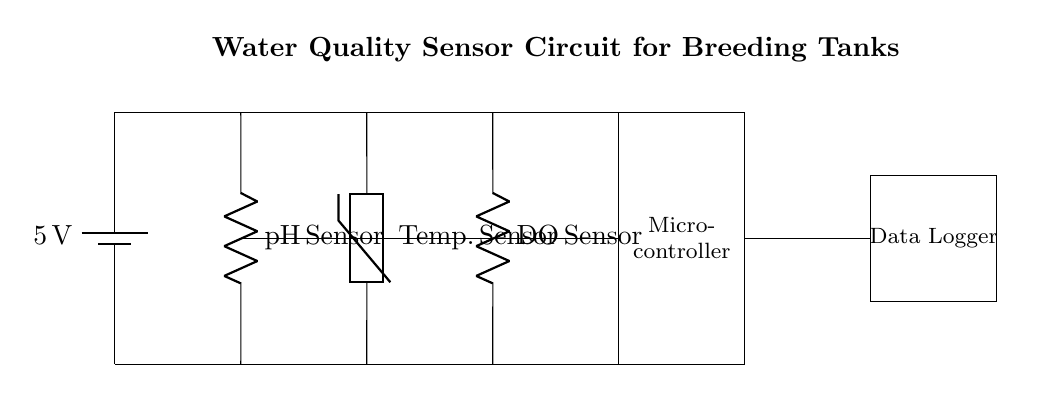What is the main power supply voltage for this circuit? The main power supply voltage is indicated by the battery symbol at the start of the circuit, which specifies it as 5 volts.
Answer: 5 volts What type of sensors are used in this circuit? Three types of sensors are shown: a pH sensor, a temperature sensor (thermistor), and a dissolved oxygen sensor, each labeled accordingly.
Answer: pH sensor, temperature sensor, dissolved oxygen sensor How many sensors connect to the microcontroller? The diagram shows three distinct sensors (pH, temperature, and dissolved oxygen) all connecting to a single microcontroller, indicated by the lines converging into the microcontroller from each sensor.
Answer: Three sensors What is the function of the data logger in this circuit? The data logger is connected at the output of the microcontroller, taking in the processed data from the sensors, emphasizing its role in recording and possibly transmitting data for monitoring water quality.
Answer: Recording data What are the connections for the sensors to the microcontroller? Each sensor has a wire running from its output upwards to the microcontroller; specifically, they join into one line before entering the microcontroller, indicating that all sensor outputs feed into the microcontroller for processing.
Answer: Common connection to the microcontroller What does the rectangle represent in the circuit diagram? The rectangle enclosing the “Microcontroller” label represents the physical microcontroller device that processes the signals from the sensors, functioning as the brain of the circuit.
Answer: Microcontroller 